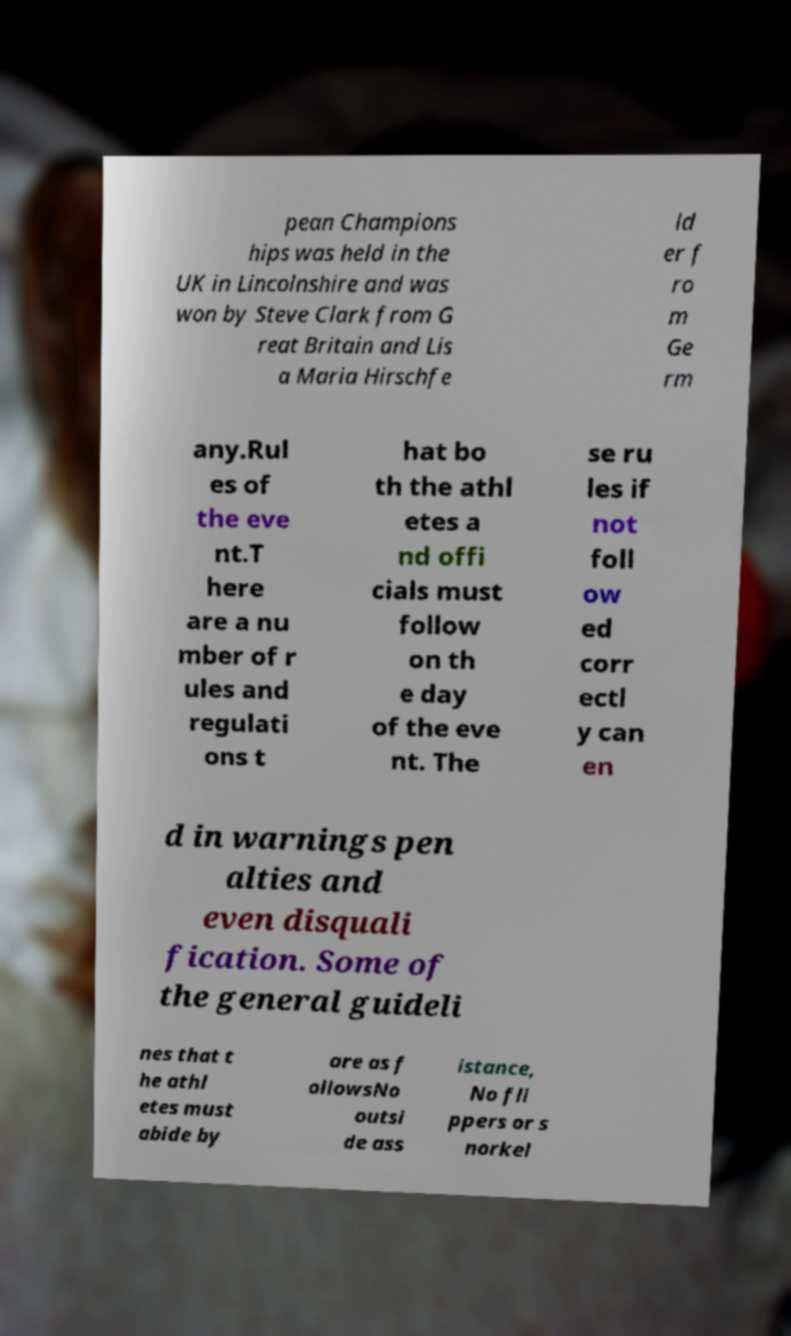What messages or text are displayed in this image? I need them in a readable, typed format. pean Champions hips was held in the UK in Lincolnshire and was won by Steve Clark from G reat Britain and Lis a Maria Hirschfe ld er f ro m Ge rm any.Rul es of the eve nt.T here are a nu mber of r ules and regulati ons t hat bo th the athl etes a nd offi cials must follow on th e day of the eve nt. The se ru les if not foll ow ed corr ectl y can en d in warnings pen alties and even disquali fication. Some of the general guideli nes that t he athl etes must abide by are as f ollowsNo outsi de ass istance, No fli ppers or s norkel 